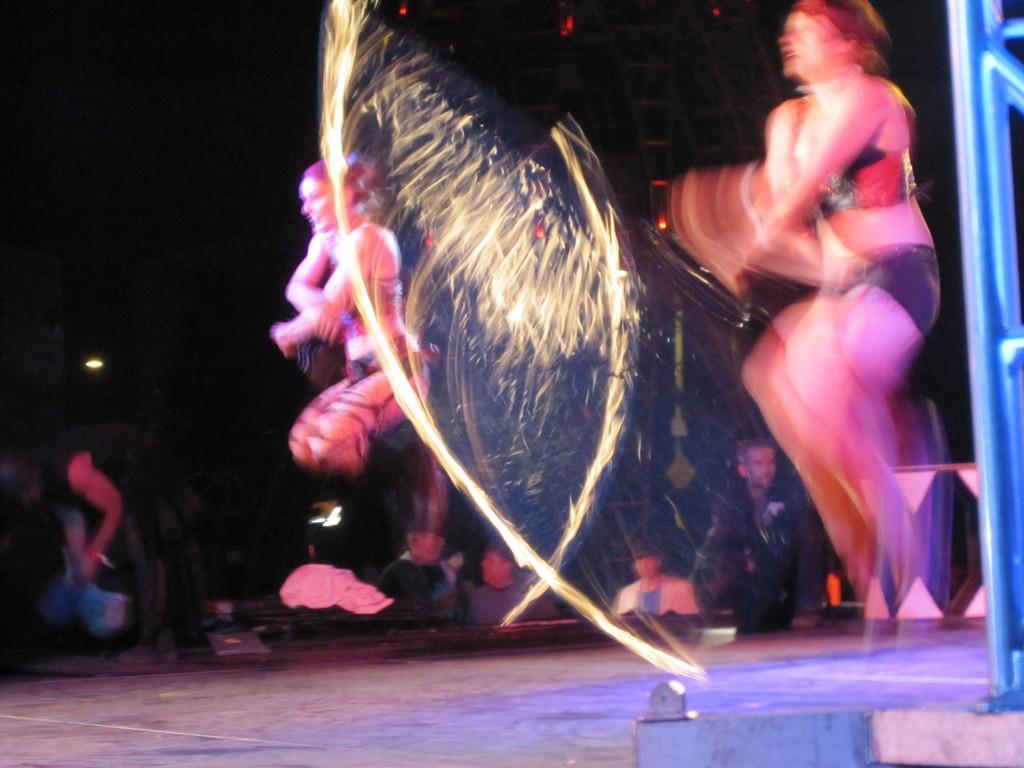Describe this image in one or two sentences. In this image there are two women performing a dance on a stage and audience are seeing their performance. 